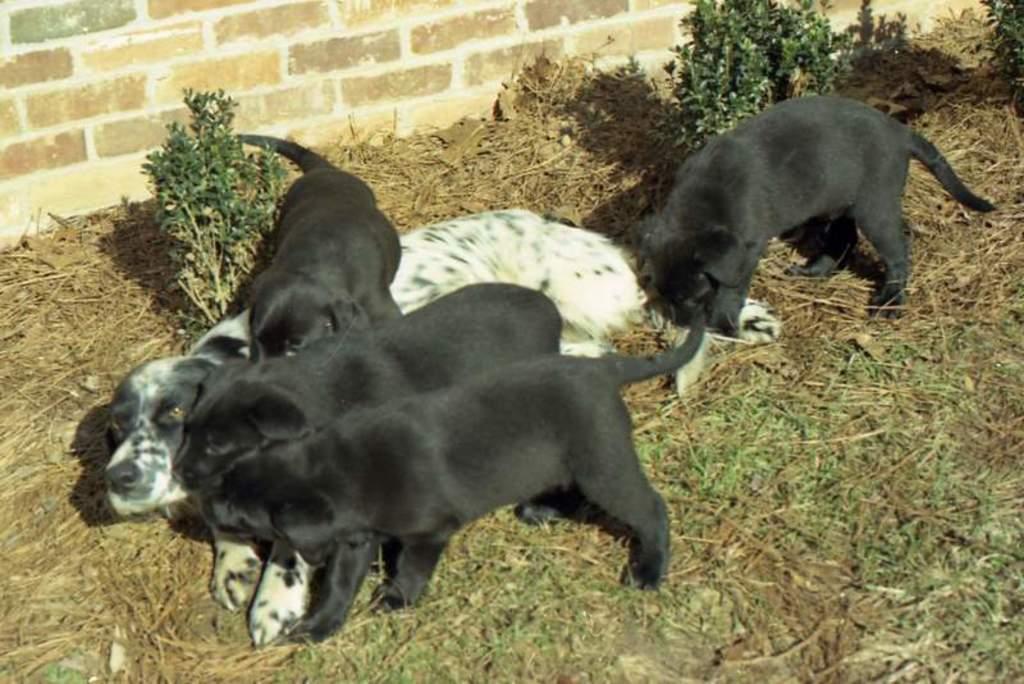How would you summarize this image in a sentence or two? In this image we can see dog and puppies on the ground. 